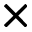<formula> <loc_0><loc_0><loc_500><loc_500>\times</formula> 